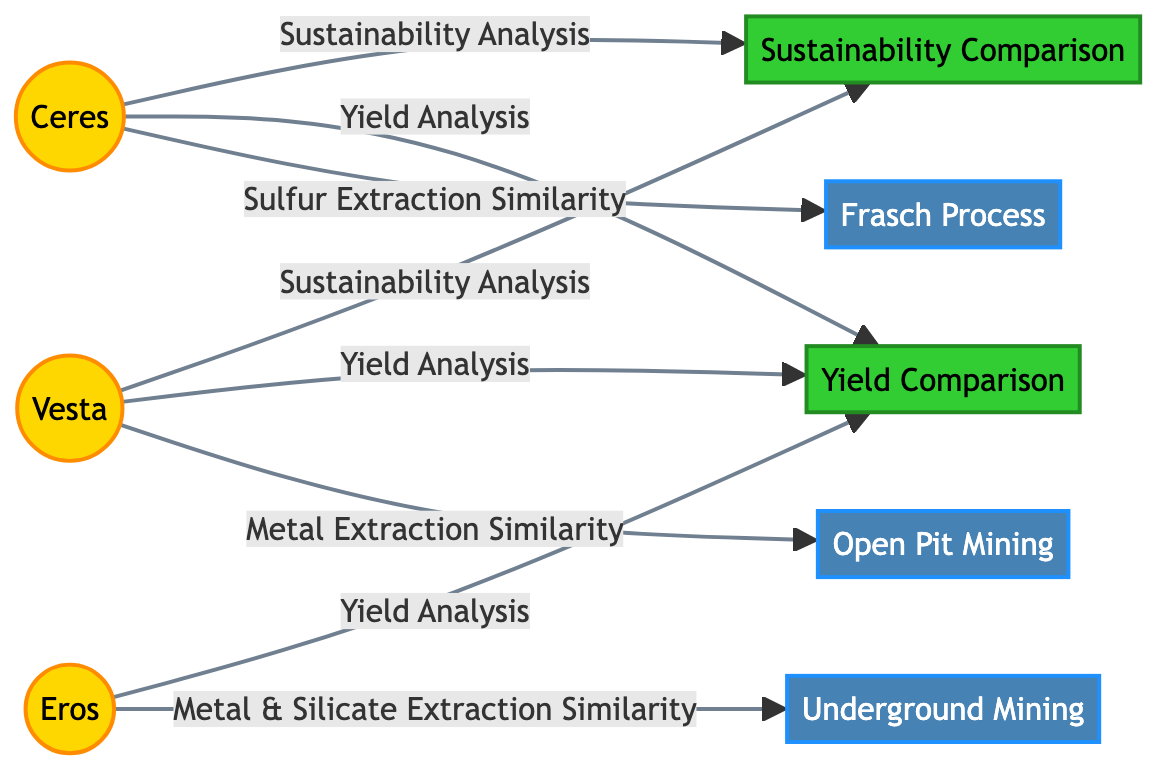What are the three asteroids mentioned in the diagram? The diagram lists Ceres, Vesta, and Eros as the three asteroids.
Answer: Ceres, Vesta, Eros Which extraction method is associated with Ceres? Ceres is linked with the Frasch Process for sulfur extraction similarity.
Answer: Frasch Process How many mining processes are depicted in the diagram? Three mining processes are shown: Frasch Process, Open Pit Mining, and Underground Mining.
Answer: 3 What type of mining is associated with Vesta? Vesta is connected to Open Pit Mining for metal extraction similarity.
Answer: Open Pit Mining Which asteroids undergo yield analysis? The yield analysis includes Ceres, Vesta, and Eros.
Answer: Ceres, Vesta, Eros Which asteroid is used for both metal and silicate extraction? Eros is identified for metal and silicate extraction similarity with Underground Mining.
Answer: Eros What is the focus of the sustainability analysis in the diagram? The sustainability analysis is focused on Ceres and Vesta.
Answer: Ceres, Vesta Which asteroid has a connection to both yield and sustainability analysis? Ceres has connections to both yield and sustainability analysis.
Answer: Ceres What color represents the asteroids in the diagram? The asteroids are represented with a yellow-gold fill (#FFD700).
Answer: Yellow-gold 